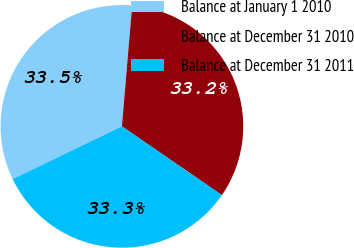Convert chart. <chart><loc_0><loc_0><loc_500><loc_500><pie_chart><fcel>Balance at January 1 2010<fcel>Balance at December 31 2010<fcel>Balance at December 31 2011<nl><fcel>33.5%<fcel>33.24%<fcel>33.26%<nl></chart> 